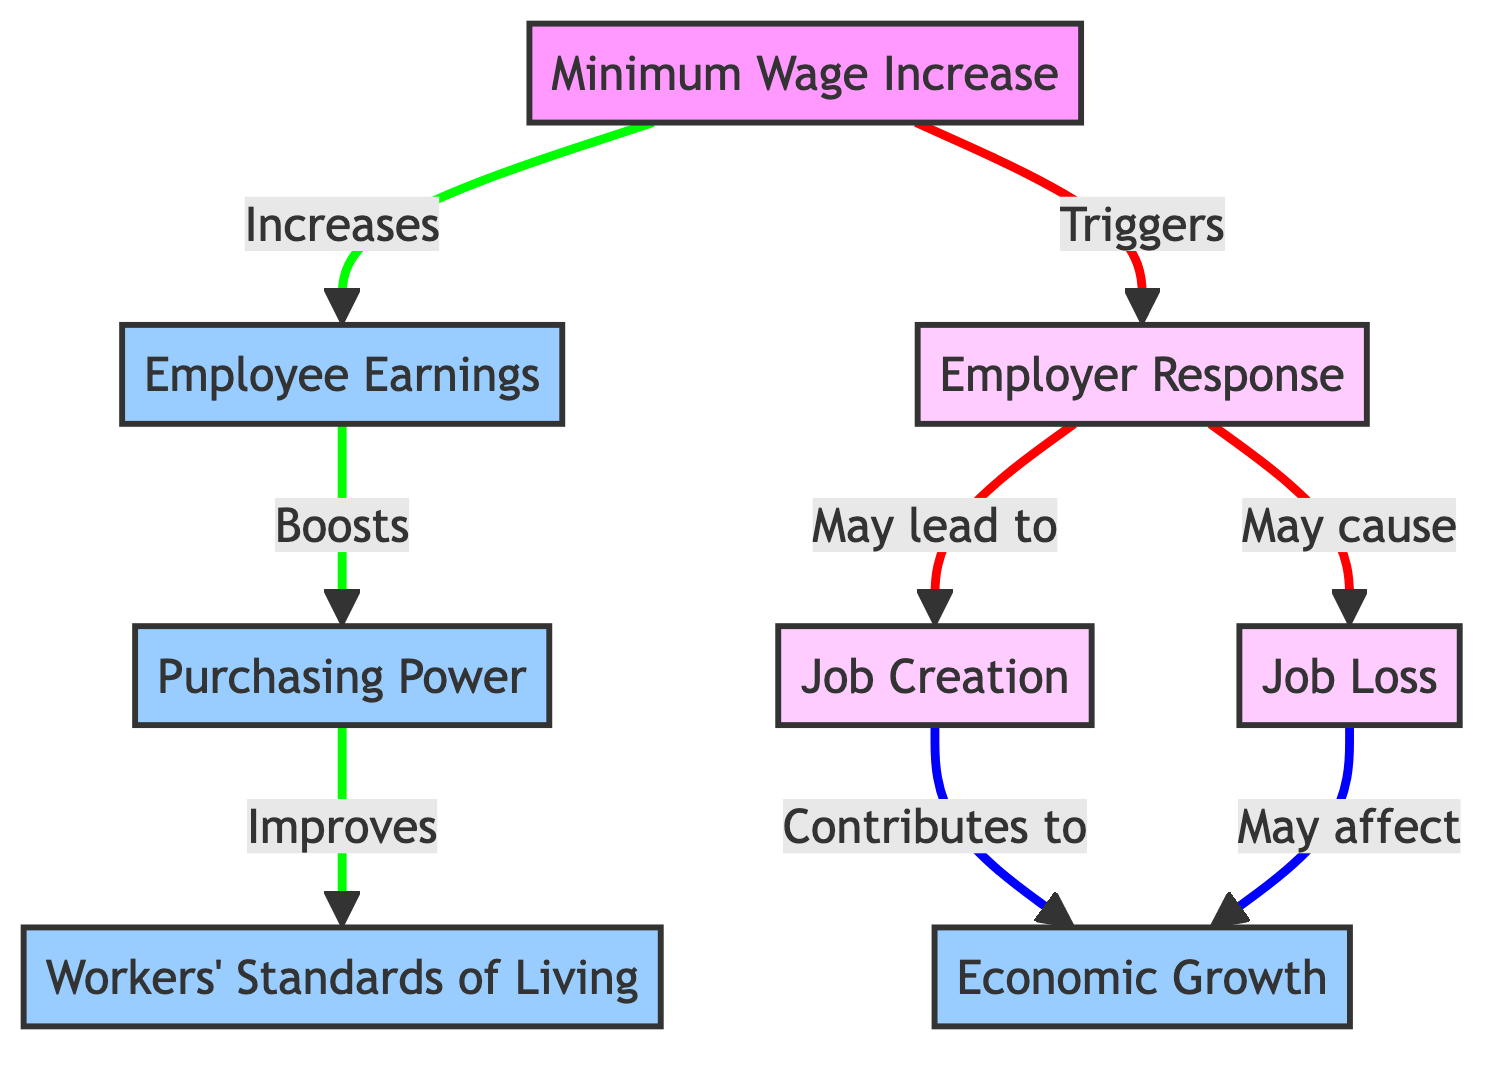What is the starting node in the diagram? The starting node is "Minimum Wage Increase," which is the first node and represents the initial change being analyzed in the diagram.
Answer: Minimum Wage Increase How many nodes are present in the diagram? By counting each unique entry in the "nodes" section of the data, there are a total of 8 nodes included.
Answer: 8 What is the relationship between "Employee Earnings" and "Purchasing Power"? The diagram indicates a direct flow from "Employee Earnings" to "Purchasing Power," stating that "Employee Earnings" boosts "Purchasing Power."
Answer: Boosts What may be the consequence of "Employer Response" according to the diagram? The "Employer Response" node may lead to either "Job Creation" or "Job Loss," indicating that employers' reactions to the wage increase can result in both positive and negative outcomes for employment.
Answer: Job Creation or Job Loss Which node connects to "Economic Growth" through "Job Creation"? The node "Job Creation" connects to "Economic Growth" in the diagram and indicates that job creation is a contributing factor to economic growth.
Answer: Job Creation How do "Job Loss" and "Job Creation" relate to "Economic Growth"? Both "Job Loss" and "Job Creation" each point to "Economic Growth," which means that while job losses can negatively affect economic growth, job creation can have a positive effect.
Answer: Both affect Economic Growth What happens to "Workers' Standards of Living" when "Purchasing Power" improves? "Purchasing Power" improves leads to an improvement in "Workers' Standards of Living" according to the diagram, showing a direct positive relationship between these two nodes.
Answer: Improves What is the flow from "Minimum Wage Increase" to "Employer Response"? The diagram presents a flow from "Minimum Wage Increase" to "Employer Response," indicating that an increase in the minimum wage triggers a response from employers as they adjust to the wage policy change.
Answer: Triggers 